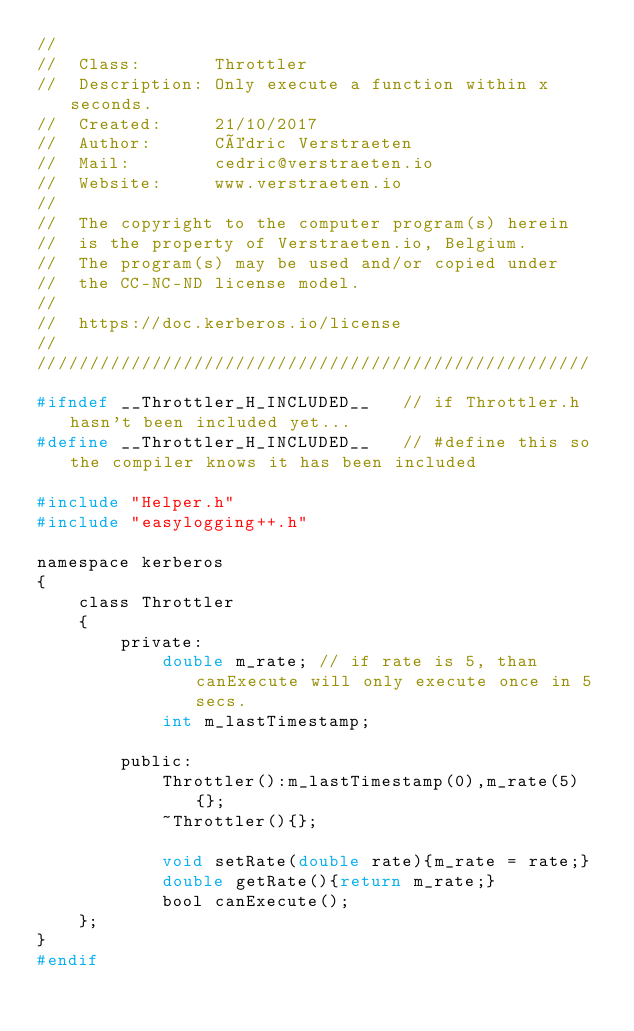Convert code to text. <code><loc_0><loc_0><loc_500><loc_500><_C_>//
//  Class:       Throttler
//  Description: Only execute a function within x seconds.
//  Created:     21/10/2017
//  Author:      Cédric Verstraeten
//  Mail:        cedric@verstraeten.io
//  Website:     www.verstraeten.io
//
//  The copyright to the computer program(s) herein
//  is the property of Verstraeten.io, Belgium.
//  The program(s) may be used and/or copied under
//  the CC-NC-ND license model.
//
//  https://doc.kerberos.io/license
//
/////////////////////////////////////////////////////

#ifndef __Throttler_H_INCLUDED__   // if Throttler.h hasn't been included yet...
#define __Throttler_H_INCLUDED__   // #define this so the compiler knows it has been included

#include "Helper.h"
#include "easylogging++.h"

namespace kerberos
{
    class Throttler
    {
        private:
            double m_rate; // if rate is 5, than canExecute will only execute once in 5 secs.
            int m_lastTimestamp;

        public:
            Throttler():m_lastTimestamp(0),m_rate(5){};
            ~Throttler(){};

            void setRate(double rate){m_rate = rate;}
            double getRate(){return m_rate;}
            bool canExecute();
    };
}
#endif
</code> 